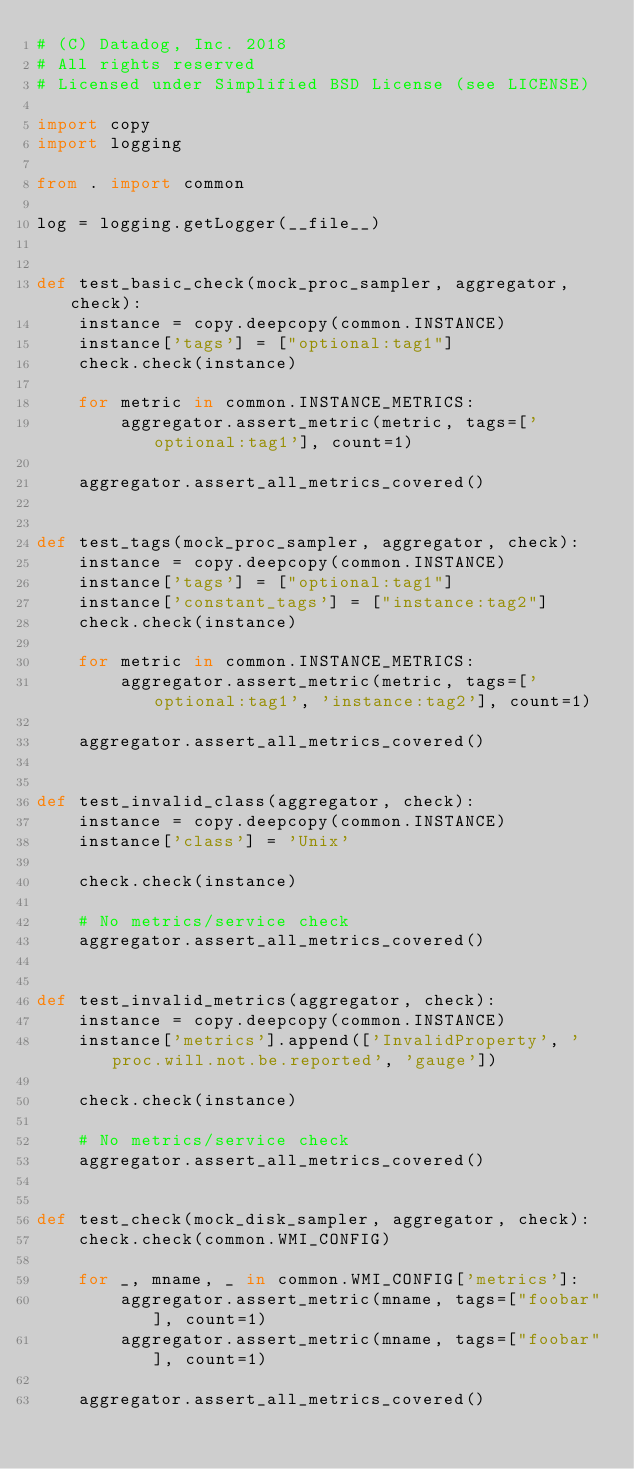Convert code to text. <code><loc_0><loc_0><loc_500><loc_500><_Python_># (C) Datadog, Inc. 2018
# All rights reserved
# Licensed under Simplified BSD License (see LICENSE)

import copy
import logging

from . import common

log = logging.getLogger(__file__)


def test_basic_check(mock_proc_sampler, aggregator, check):
    instance = copy.deepcopy(common.INSTANCE)
    instance['tags'] = ["optional:tag1"]
    check.check(instance)

    for metric in common.INSTANCE_METRICS:
        aggregator.assert_metric(metric, tags=['optional:tag1'], count=1)

    aggregator.assert_all_metrics_covered()


def test_tags(mock_proc_sampler, aggregator, check):
    instance = copy.deepcopy(common.INSTANCE)
    instance['tags'] = ["optional:tag1"]
    instance['constant_tags'] = ["instance:tag2"]
    check.check(instance)

    for metric in common.INSTANCE_METRICS:
        aggregator.assert_metric(metric, tags=['optional:tag1', 'instance:tag2'], count=1)

    aggregator.assert_all_metrics_covered()


def test_invalid_class(aggregator, check):
    instance = copy.deepcopy(common.INSTANCE)
    instance['class'] = 'Unix'

    check.check(instance)

    # No metrics/service check
    aggregator.assert_all_metrics_covered()


def test_invalid_metrics(aggregator, check):
    instance = copy.deepcopy(common.INSTANCE)
    instance['metrics'].append(['InvalidProperty', 'proc.will.not.be.reported', 'gauge'])

    check.check(instance)

    # No metrics/service check
    aggregator.assert_all_metrics_covered()


def test_check(mock_disk_sampler, aggregator, check):
    check.check(common.WMI_CONFIG)

    for _, mname, _ in common.WMI_CONFIG['metrics']:
        aggregator.assert_metric(mname, tags=["foobar"], count=1)
        aggregator.assert_metric(mname, tags=["foobar"], count=1)

    aggregator.assert_all_metrics_covered()
</code> 